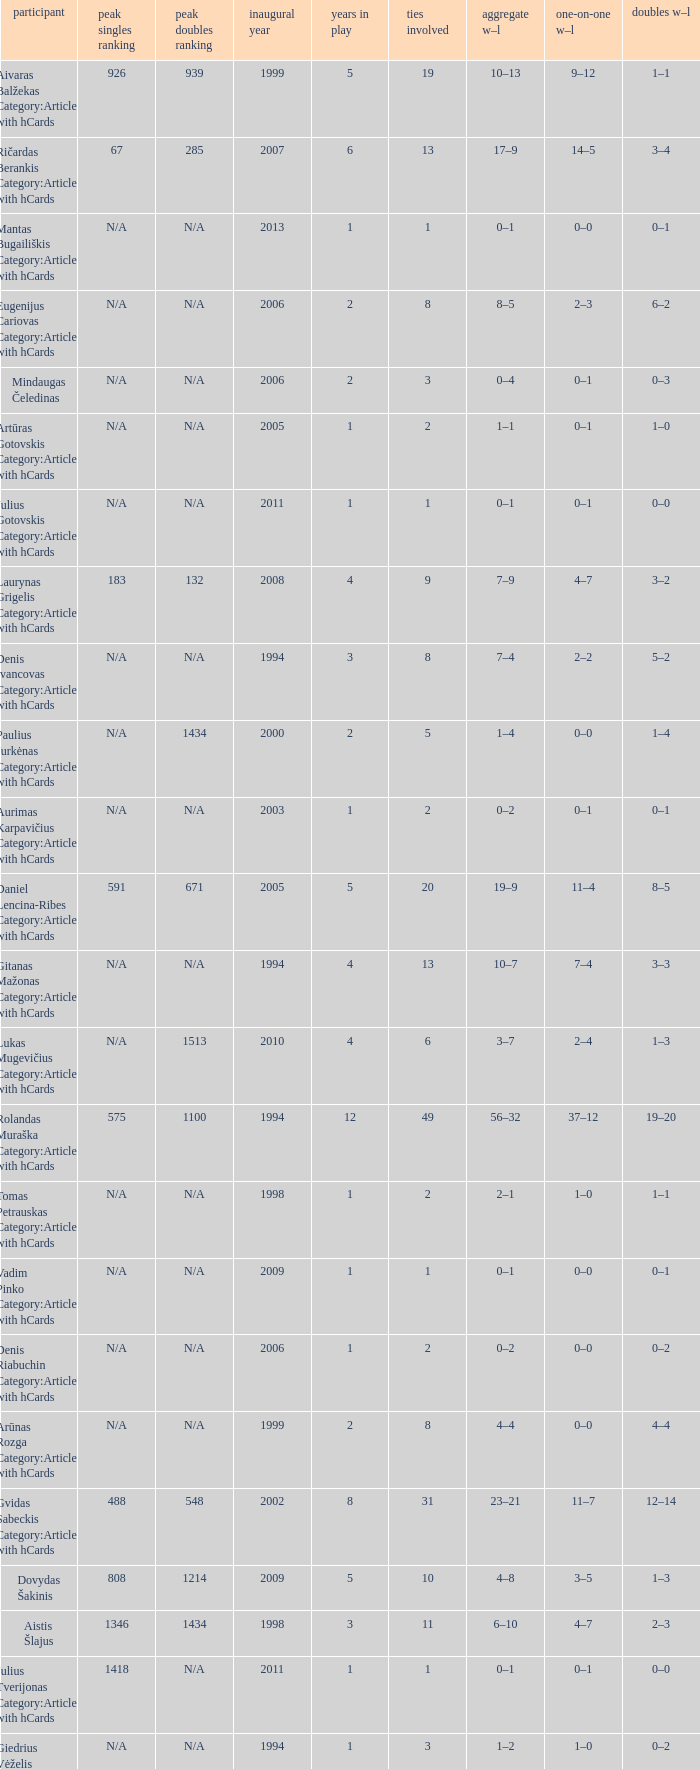Name the minimum tiesplayed for 6 years 13.0. 